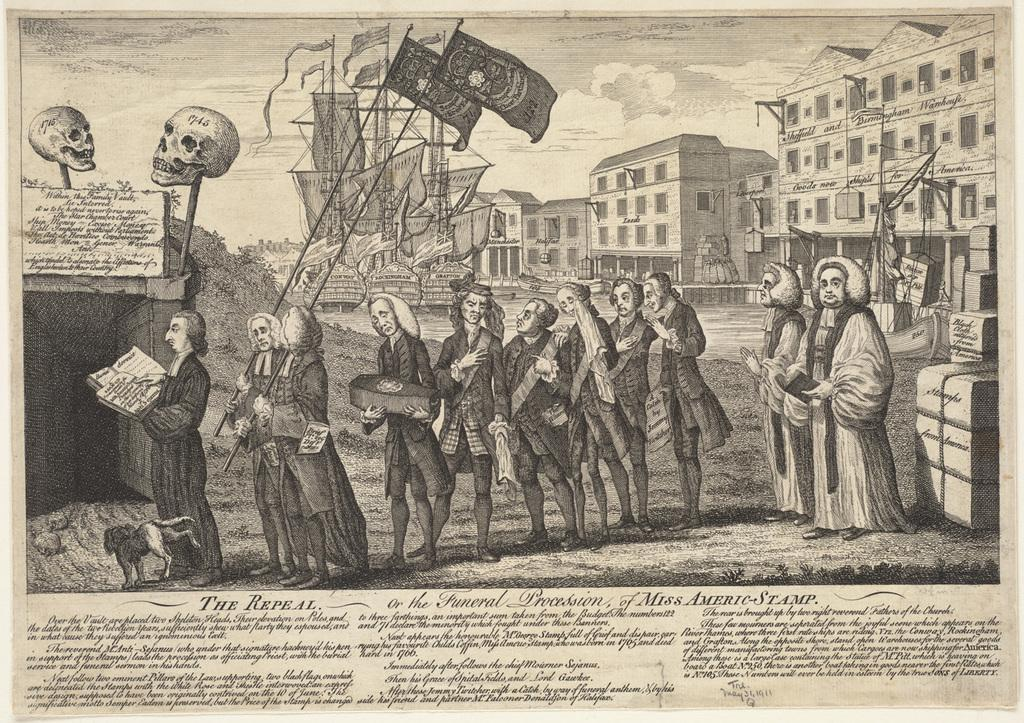What is the main subject of the image? There is an art piece in the image. What is depicted within the art piece? The art piece depicts people and buildings. Is there any text associated with the art piece? Yes, there is text at the bottom of the art. What type of truck can be seen in the art piece? There is no truck depicted in the art piece; it features people and buildings. What role does zinc play in the creation of the art piece? There is no information about the materials used in the creation of the art piece, so it cannot be determined if zinc was used. 